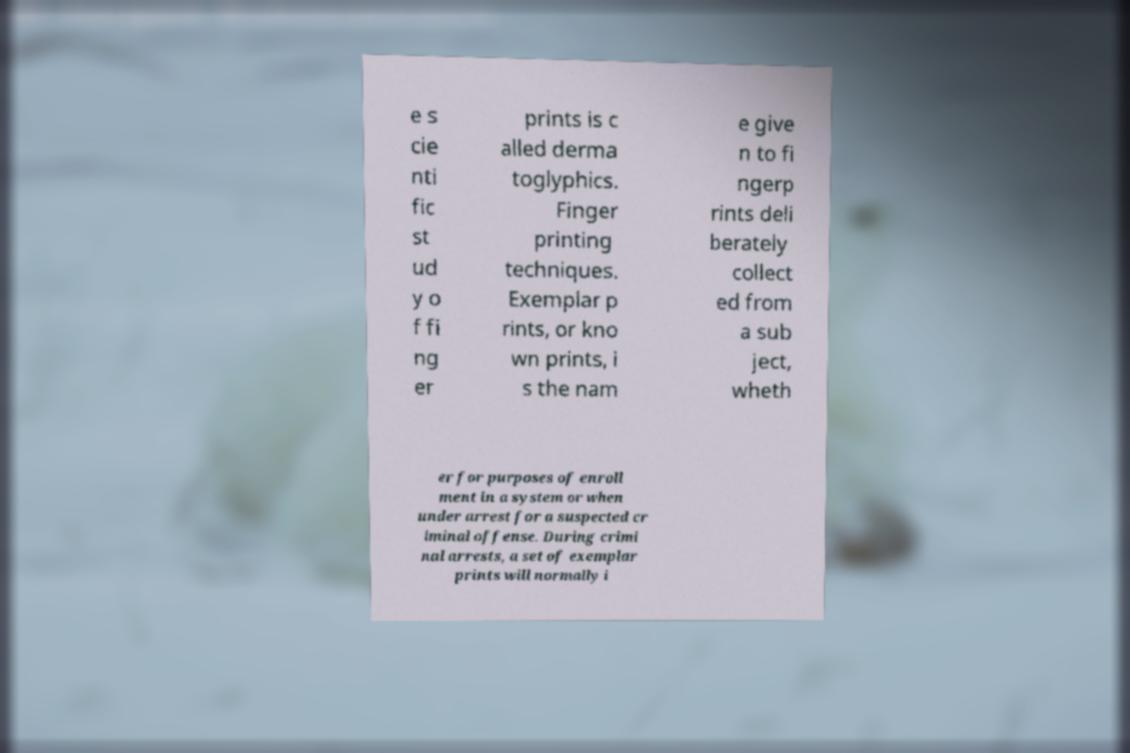For documentation purposes, I need the text within this image transcribed. Could you provide that? e s cie nti fic st ud y o f fi ng er prints is c alled derma toglyphics. Finger printing techniques. Exemplar p rints, or kno wn prints, i s the nam e give n to fi ngerp rints deli berately collect ed from a sub ject, wheth er for purposes of enroll ment in a system or when under arrest for a suspected cr iminal offense. During crimi nal arrests, a set of exemplar prints will normally i 